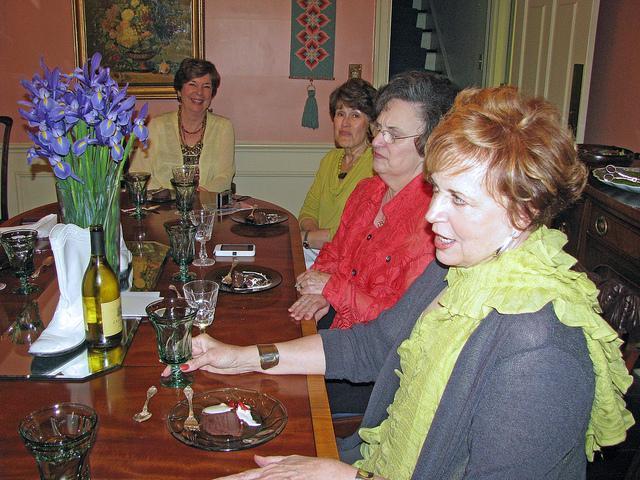How many people are there?
Give a very brief answer. 4. How many potted plants are there?
Give a very brief answer. 1. How many people are in the photo?
Give a very brief answer. 4. How many wine glasses can be seen?
Give a very brief answer. 2. How many hot dogs are shown?
Give a very brief answer. 0. 